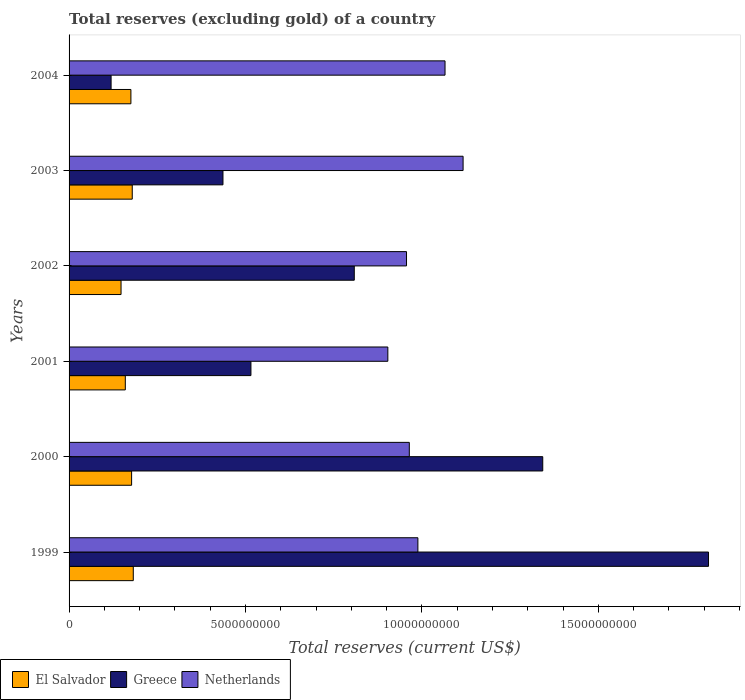How many groups of bars are there?
Provide a short and direct response. 6. Are the number of bars on each tick of the Y-axis equal?
Your response must be concise. Yes. How many bars are there on the 5th tick from the top?
Keep it short and to the point. 3. How many bars are there on the 2nd tick from the bottom?
Ensure brevity in your answer.  3. What is the label of the 5th group of bars from the top?
Provide a succinct answer. 2000. What is the total reserves (excluding gold) in Netherlands in 2001?
Offer a very short reply. 9.03e+09. Across all years, what is the maximum total reserves (excluding gold) in Netherlands?
Offer a very short reply. 1.12e+1. Across all years, what is the minimum total reserves (excluding gold) in Netherlands?
Keep it short and to the point. 9.03e+09. What is the total total reserves (excluding gold) in Netherlands in the graph?
Offer a terse response. 5.99e+1. What is the difference between the total reserves (excluding gold) in Netherlands in 2000 and that in 2002?
Make the answer very short. 7.93e+07. What is the difference between the total reserves (excluding gold) in El Salvador in 2000 and the total reserves (excluding gold) in Netherlands in 1999?
Give a very brief answer. -8.11e+09. What is the average total reserves (excluding gold) in El Salvador per year?
Your response must be concise. 1.70e+09. In the year 2003, what is the difference between the total reserves (excluding gold) in El Salvador and total reserves (excluding gold) in Greece?
Offer a very short reply. -2.57e+09. What is the ratio of the total reserves (excluding gold) in Netherlands in 2000 to that in 2002?
Your response must be concise. 1.01. Is the difference between the total reserves (excluding gold) in El Salvador in 1999 and 2004 greater than the difference between the total reserves (excluding gold) in Greece in 1999 and 2004?
Make the answer very short. No. What is the difference between the highest and the second highest total reserves (excluding gold) in Netherlands?
Keep it short and to the point. 5.12e+08. What is the difference between the highest and the lowest total reserves (excluding gold) in El Salvador?
Provide a succinct answer. 3.47e+08. Is the sum of the total reserves (excluding gold) in El Salvador in 2001 and 2003 greater than the maximum total reserves (excluding gold) in Netherlands across all years?
Your response must be concise. No. What does the 2nd bar from the top in 2001 represents?
Provide a succinct answer. Greece. What does the 2nd bar from the bottom in 2000 represents?
Provide a short and direct response. Greece. How many bars are there?
Give a very brief answer. 18. Are the values on the major ticks of X-axis written in scientific E-notation?
Ensure brevity in your answer.  No. Does the graph contain any zero values?
Make the answer very short. No. Where does the legend appear in the graph?
Ensure brevity in your answer.  Bottom left. How many legend labels are there?
Offer a very short reply. 3. How are the legend labels stacked?
Offer a very short reply. Horizontal. What is the title of the graph?
Keep it short and to the point. Total reserves (excluding gold) of a country. What is the label or title of the X-axis?
Your answer should be very brief. Total reserves (current US$). What is the label or title of the Y-axis?
Give a very brief answer. Years. What is the Total reserves (current US$) in El Salvador in 1999?
Provide a succinct answer. 1.82e+09. What is the Total reserves (current US$) of Greece in 1999?
Your response must be concise. 1.81e+1. What is the Total reserves (current US$) of Netherlands in 1999?
Ensure brevity in your answer.  9.89e+09. What is the Total reserves (current US$) in El Salvador in 2000?
Provide a short and direct response. 1.77e+09. What is the Total reserves (current US$) of Greece in 2000?
Make the answer very short. 1.34e+1. What is the Total reserves (current US$) of Netherlands in 2000?
Offer a very short reply. 9.64e+09. What is the Total reserves (current US$) in El Salvador in 2001?
Ensure brevity in your answer.  1.59e+09. What is the Total reserves (current US$) of Greece in 2001?
Provide a succinct answer. 5.15e+09. What is the Total reserves (current US$) of Netherlands in 2001?
Keep it short and to the point. 9.03e+09. What is the Total reserves (current US$) of El Salvador in 2002?
Your response must be concise. 1.47e+09. What is the Total reserves (current US$) of Greece in 2002?
Provide a succinct answer. 8.08e+09. What is the Total reserves (current US$) in Netherlands in 2002?
Provide a short and direct response. 9.56e+09. What is the Total reserves (current US$) in El Salvador in 2003?
Your answer should be compact. 1.79e+09. What is the Total reserves (current US$) of Greece in 2003?
Offer a terse response. 4.36e+09. What is the Total reserves (current US$) of Netherlands in 2003?
Provide a succinct answer. 1.12e+1. What is the Total reserves (current US$) in El Salvador in 2004?
Give a very brief answer. 1.75e+09. What is the Total reserves (current US$) in Greece in 2004?
Provide a short and direct response. 1.19e+09. What is the Total reserves (current US$) in Netherlands in 2004?
Your response must be concise. 1.07e+1. Across all years, what is the maximum Total reserves (current US$) in El Salvador?
Give a very brief answer. 1.82e+09. Across all years, what is the maximum Total reserves (current US$) in Greece?
Offer a terse response. 1.81e+1. Across all years, what is the maximum Total reserves (current US$) of Netherlands?
Your answer should be very brief. 1.12e+1. Across all years, what is the minimum Total reserves (current US$) of El Salvador?
Ensure brevity in your answer.  1.47e+09. Across all years, what is the minimum Total reserves (current US$) of Greece?
Provide a succinct answer. 1.19e+09. Across all years, what is the minimum Total reserves (current US$) of Netherlands?
Your response must be concise. 9.03e+09. What is the total Total reserves (current US$) in El Salvador in the graph?
Offer a terse response. 1.02e+1. What is the total Total reserves (current US$) of Greece in the graph?
Your response must be concise. 5.03e+1. What is the total Total reserves (current US$) in Netherlands in the graph?
Give a very brief answer. 5.99e+1. What is the difference between the Total reserves (current US$) in El Salvador in 1999 and that in 2000?
Make the answer very short. 4.72e+07. What is the difference between the Total reserves (current US$) of Greece in 1999 and that in 2000?
Ensure brevity in your answer.  4.70e+09. What is the difference between the Total reserves (current US$) of Netherlands in 1999 and that in 2000?
Your answer should be very brief. 2.43e+08. What is the difference between the Total reserves (current US$) of El Salvador in 1999 and that in 2001?
Give a very brief answer. 2.26e+08. What is the difference between the Total reserves (current US$) of Greece in 1999 and that in 2001?
Keep it short and to the point. 1.30e+1. What is the difference between the Total reserves (current US$) of Netherlands in 1999 and that in 2001?
Provide a short and direct response. 8.51e+08. What is the difference between the Total reserves (current US$) in El Salvador in 1999 and that in 2002?
Offer a very short reply. 3.47e+08. What is the difference between the Total reserves (current US$) in Greece in 1999 and that in 2002?
Make the answer very short. 1.00e+1. What is the difference between the Total reserves (current US$) in Netherlands in 1999 and that in 2002?
Your answer should be very brief. 3.22e+08. What is the difference between the Total reserves (current US$) in El Salvador in 1999 and that in 2003?
Give a very brief answer. 2.91e+07. What is the difference between the Total reserves (current US$) of Greece in 1999 and that in 2003?
Keep it short and to the point. 1.38e+1. What is the difference between the Total reserves (current US$) in Netherlands in 1999 and that in 2003?
Keep it short and to the point. -1.28e+09. What is the difference between the Total reserves (current US$) of El Salvador in 1999 and that in 2004?
Offer a very short reply. 6.74e+07. What is the difference between the Total reserves (current US$) in Greece in 1999 and that in 2004?
Ensure brevity in your answer.  1.69e+1. What is the difference between the Total reserves (current US$) of Netherlands in 1999 and that in 2004?
Keep it short and to the point. -7.69e+08. What is the difference between the Total reserves (current US$) in El Salvador in 2000 and that in 2001?
Provide a succinct answer. 1.79e+08. What is the difference between the Total reserves (current US$) of Greece in 2000 and that in 2001?
Your answer should be compact. 8.27e+09. What is the difference between the Total reserves (current US$) of Netherlands in 2000 and that in 2001?
Your answer should be compact. 6.08e+08. What is the difference between the Total reserves (current US$) in El Salvador in 2000 and that in 2002?
Provide a short and direct response. 3.00e+08. What is the difference between the Total reserves (current US$) of Greece in 2000 and that in 2002?
Offer a very short reply. 5.34e+09. What is the difference between the Total reserves (current US$) of Netherlands in 2000 and that in 2002?
Offer a terse response. 7.93e+07. What is the difference between the Total reserves (current US$) of El Salvador in 2000 and that in 2003?
Ensure brevity in your answer.  -1.81e+07. What is the difference between the Total reserves (current US$) in Greece in 2000 and that in 2003?
Make the answer very short. 9.06e+09. What is the difference between the Total reserves (current US$) of Netherlands in 2000 and that in 2003?
Your response must be concise. -1.52e+09. What is the difference between the Total reserves (current US$) of El Salvador in 2000 and that in 2004?
Offer a very short reply. 2.02e+07. What is the difference between the Total reserves (current US$) of Greece in 2000 and that in 2004?
Offer a terse response. 1.22e+1. What is the difference between the Total reserves (current US$) of Netherlands in 2000 and that in 2004?
Ensure brevity in your answer.  -1.01e+09. What is the difference between the Total reserves (current US$) of El Salvador in 2001 and that in 2002?
Offer a very short reply. 1.21e+08. What is the difference between the Total reserves (current US$) in Greece in 2001 and that in 2002?
Your answer should be very brief. -2.93e+09. What is the difference between the Total reserves (current US$) of Netherlands in 2001 and that in 2002?
Provide a succinct answer. -5.29e+08. What is the difference between the Total reserves (current US$) of El Salvador in 2001 and that in 2003?
Your answer should be very brief. -1.97e+08. What is the difference between the Total reserves (current US$) in Greece in 2001 and that in 2003?
Ensure brevity in your answer.  7.93e+08. What is the difference between the Total reserves (current US$) in Netherlands in 2001 and that in 2003?
Your answer should be very brief. -2.13e+09. What is the difference between the Total reserves (current US$) in El Salvador in 2001 and that in 2004?
Give a very brief answer. -1.59e+08. What is the difference between the Total reserves (current US$) of Greece in 2001 and that in 2004?
Your response must be concise. 3.96e+09. What is the difference between the Total reserves (current US$) of Netherlands in 2001 and that in 2004?
Your answer should be compact. -1.62e+09. What is the difference between the Total reserves (current US$) of El Salvador in 2002 and that in 2003?
Make the answer very short. -3.18e+08. What is the difference between the Total reserves (current US$) of Greece in 2002 and that in 2003?
Give a very brief answer. 3.72e+09. What is the difference between the Total reserves (current US$) in Netherlands in 2002 and that in 2003?
Your response must be concise. -1.60e+09. What is the difference between the Total reserves (current US$) in El Salvador in 2002 and that in 2004?
Your answer should be compact. -2.80e+08. What is the difference between the Total reserves (current US$) in Greece in 2002 and that in 2004?
Ensure brevity in your answer.  6.89e+09. What is the difference between the Total reserves (current US$) in Netherlands in 2002 and that in 2004?
Offer a terse response. -1.09e+09. What is the difference between the Total reserves (current US$) of El Salvador in 2003 and that in 2004?
Provide a short and direct response. 3.83e+07. What is the difference between the Total reserves (current US$) of Greece in 2003 and that in 2004?
Provide a succinct answer. 3.17e+09. What is the difference between the Total reserves (current US$) in Netherlands in 2003 and that in 2004?
Provide a succinct answer. 5.12e+08. What is the difference between the Total reserves (current US$) of El Salvador in 1999 and the Total reserves (current US$) of Greece in 2000?
Keep it short and to the point. -1.16e+1. What is the difference between the Total reserves (current US$) in El Salvador in 1999 and the Total reserves (current US$) in Netherlands in 2000?
Provide a succinct answer. -7.82e+09. What is the difference between the Total reserves (current US$) of Greece in 1999 and the Total reserves (current US$) of Netherlands in 2000?
Your response must be concise. 8.48e+09. What is the difference between the Total reserves (current US$) in El Salvador in 1999 and the Total reserves (current US$) in Greece in 2001?
Ensure brevity in your answer.  -3.33e+09. What is the difference between the Total reserves (current US$) in El Salvador in 1999 and the Total reserves (current US$) in Netherlands in 2001?
Your answer should be compact. -7.21e+09. What is the difference between the Total reserves (current US$) in Greece in 1999 and the Total reserves (current US$) in Netherlands in 2001?
Your answer should be compact. 9.09e+09. What is the difference between the Total reserves (current US$) in El Salvador in 1999 and the Total reserves (current US$) in Greece in 2002?
Give a very brief answer. -6.26e+09. What is the difference between the Total reserves (current US$) of El Salvador in 1999 and the Total reserves (current US$) of Netherlands in 2002?
Make the answer very short. -7.74e+09. What is the difference between the Total reserves (current US$) in Greece in 1999 and the Total reserves (current US$) in Netherlands in 2002?
Offer a very short reply. 8.56e+09. What is the difference between the Total reserves (current US$) in El Salvador in 1999 and the Total reserves (current US$) in Greece in 2003?
Your response must be concise. -2.54e+09. What is the difference between the Total reserves (current US$) of El Salvador in 1999 and the Total reserves (current US$) of Netherlands in 2003?
Offer a terse response. -9.35e+09. What is the difference between the Total reserves (current US$) of Greece in 1999 and the Total reserves (current US$) of Netherlands in 2003?
Your response must be concise. 6.96e+09. What is the difference between the Total reserves (current US$) of El Salvador in 1999 and the Total reserves (current US$) of Greece in 2004?
Your answer should be very brief. 6.29e+08. What is the difference between the Total reserves (current US$) of El Salvador in 1999 and the Total reserves (current US$) of Netherlands in 2004?
Ensure brevity in your answer.  -8.84e+09. What is the difference between the Total reserves (current US$) in Greece in 1999 and the Total reserves (current US$) in Netherlands in 2004?
Offer a very short reply. 7.47e+09. What is the difference between the Total reserves (current US$) of El Salvador in 2000 and the Total reserves (current US$) of Greece in 2001?
Offer a very short reply. -3.38e+09. What is the difference between the Total reserves (current US$) of El Salvador in 2000 and the Total reserves (current US$) of Netherlands in 2001?
Ensure brevity in your answer.  -7.26e+09. What is the difference between the Total reserves (current US$) of Greece in 2000 and the Total reserves (current US$) of Netherlands in 2001?
Offer a very short reply. 4.39e+09. What is the difference between the Total reserves (current US$) in El Salvador in 2000 and the Total reserves (current US$) in Greece in 2002?
Keep it short and to the point. -6.31e+09. What is the difference between the Total reserves (current US$) in El Salvador in 2000 and the Total reserves (current US$) in Netherlands in 2002?
Provide a short and direct response. -7.79e+09. What is the difference between the Total reserves (current US$) in Greece in 2000 and the Total reserves (current US$) in Netherlands in 2002?
Your answer should be very brief. 3.86e+09. What is the difference between the Total reserves (current US$) of El Salvador in 2000 and the Total reserves (current US$) of Greece in 2003?
Offer a terse response. -2.59e+09. What is the difference between the Total reserves (current US$) in El Salvador in 2000 and the Total reserves (current US$) in Netherlands in 2003?
Keep it short and to the point. -9.39e+09. What is the difference between the Total reserves (current US$) of Greece in 2000 and the Total reserves (current US$) of Netherlands in 2003?
Provide a succinct answer. 2.26e+09. What is the difference between the Total reserves (current US$) in El Salvador in 2000 and the Total reserves (current US$) in Greece in 2004?
Provide a short and direct response. 5.82e+08. What is the difference between the Total reserves (current US$) of El Salvador in 2000 and the Total reserves (current US$) of Netherlands in 2004?
Offer a terse response. -8.88e+09. What is the difference between the Total reserves (current US$) in Greece in 2000 and the Total reserves (current US$) in Netherlands in 2004?
Make the answer very short. 2.77e+09. What is the difference between the Total reserves (current US$) of El Salvador in 2001 and the Total reserves (current US$) of Greece in 2002?
Make the answer very short. -6.49e+09. What is the difference between the Total reserves (current US$) of El Salvador in 2001 and the Total reserves (current US$) of Netherlands in 2002?
Ensure brevity in your answer.  -7.97e+09. What is the difference between the Total reserves (current US$) of Greece in 2001 and the Total reserves (current US$) of Netherlands in 2002?
Ensure brevity in your answer.  -4.41e+09. What is the difference between the Total reserves (current US$) in El Salvador in 2001 and the Total reserves (current US$) in Greece in 2003?
Keep it short and to the point. -2.77e+09. What is the difference between the Total reserves (current US$) of El Salvador in 2001 and the Total reserves (current US$) of Netherlands in 2003?
Provide a short and direct response. -9.57e+09. What is the difference between the Total reserves (current US$) in Greece in 2001 and the Total reserves (current US$) in Netherlands in 2003?
Your answer should be compact. -6.01e+09. What is the difference between the Total reserves (current US$) in El Salvador in 2001 and the Total reserves (current US$) in Greece in 2004?
Your answer should be very brief. 4.03e+08. What is the difference between the Total reserves (current US$) in El Salvador in 2001 and the Total reserves (current US$) in Netherlands in 2004?
Your response must be concise. -9.06e+09. What is the difference between the Total reserves (current US$) in Greece in 2001 and the Total reserves (current US$) in Netherlands in 2004?
Ensure brevity in your answer.  -5.50e+09. What is the difference between the Total reserves (current US$) in El Salvador in 2002 and the Total reserves (current US$) in Greece in 2003?
Make the answer very short. -2.89e+09. What is the difference between the Total reserves (current US$) in El Salvador in 2002 and the Total reserves (current US$) in Netherlands in 2003?
Keep it short and to the point. -9.69e+09. What is the difference between the Total reserves (current US$) of Greece in 2002 and the Total reserves (current US$) of Netherlands in 2003?
Your answer should be compact. -3.08e+09. What is the difference between the Total reserves (current US$) of El Salvador in 2002 and the Total reserves (current US$) of Greece in 2004?
Provide a short and direct response. 2.82e+08. What is the difference between the Total reserves (current US$) in El Salvador in 2002 and the Total reserves (current US$) in Netherlands in 2004?
Offer a terse response. -9.18e+09. What is the difference between the Total reserves (current US$) of Greece in 2002 and the Total reserves (current US$) of Netherlands in 2004?
Your response must be concise. -2.57e+09. What is the difference between the Total reserves (current US$) in El Salvador in 2003 and the Total reserves (current US$) in Greece in 2004?
Provide a succinct answer. 6.00e+08. What is the difference between the Total reserves (current US$) of El Salvador in 2003 and the Total reserves (current US$) of Netherlands in 2004?
Provide a succinct answer. -8.86e+09. What is the difference between the Total reserves (current US$) of Greece in 2003 and the Total reserves (current US$) of Netherlands in 2004?
Provide a succinct answer. -6.29e+09. What is the average Total reserves (current US$) of El Salvador per year?
Provide a short and direct response. 1.70e+09. What is the average Total reserves (current US$) in Greece per year?
Your answer should be compact. 8.39e+09. What is the average Total reserves (current US$) of Netherlands per year?
Provide a succinct answer. 9.99e+09. In the year 1999, what is the difference between the Total reserves (current US$) in El Salvador and Total reserves (current US$) in Greece?
Your response must be concise. -1.63e+1. In the year 1999, what is the difference between the Total reserves (current US$) in El Salvador and Total reserves (current US$) in Netherlands?
Offer a very short reply. -8.07e+09. In the year 1999, what is the difference between the Total reserves (current US$) in Greece and Total reserves (current US$) in Netherlands?
Make the answer very short. 8.24e+09. In the year 2000, what is the difference between the Total reserves (current US$) of El Salvador and Total reserves (current US$) of Greece?
Your answer should be very brief. -1.17e+1. In the year 2000, what is the difference between the Total reserves (current US$) in El Salvador and Total reserves (current US$) in Netherlands?
Keep it short and to the point. -7.87e+09. In the year 2000, what is the difference between the Total reserves (current US$) of Greece and Total reserves (current US$) of Netherlands?
Provide a short and direct response. 3.78e+09. In the year 2001, what is the difference between the Total reserves (current US$) of El Salvador and Total reserves (current US$) of Greece?
Offer a very short reply. -3.56e+09. In the year 2001, what is the difference between the Total reserves (current US$) in El Salvador and Total reserves (current US$) in Netherlands?
Your answer should be very brief. -7.44e+09. In the year 2001, what is the difference between the Total reserves (current US$) in Greece and Total reserves (current US$) in Netherlands?
Give a very brief answer. -3.88e+09. In the year 2002, what is the difference between the Total reserves (current US$) in El Salvador and Total reserves (current US$) in Greece?
Keep it short and to the point. -6.61e+09. In the year 2002, what is the difference between the Total reserves (current US$) of El Salvador and Total reserves (current US$) of Netherlands?
Provide a short and direct response. -8.09e+09. In the year 2002, what is the difference between the Total reserves (current US$) of Greece and Total reserves (current US$) of Netherlands?
Give a very brief answer. -1.48e+09. In the year 2003, what is the difference between the Total reserves (current US$) of El Salvador and Total reserves (current US$) of Greece?
Ensure brevity in your answer.  -2.57e+09. In the year 2003, what is the difference between the Total reserves (current US$) in El Salvador and Total reserves (current US$) in Netherlands?
Provide a succinct answer. -9.38e+09. In the year 2003, what is the difference between the Total reserves (current US$) in Greece and Total reserves (current US$) in Netherlands?
Make the answer very short. -6.81e+09. In the year 2004, what is the difference between the Total reserves (current US$) in El Salvador and Total reserves (current US$) in Greece?
Provide a succinct answer. 5.61e+08. In the year 2004, what is the difference between the Total reserves (current US$) of El Salvador and Total reserves (current US$) of Netherlands?
Your response must be concise. -8.90e+09. In the year 2004, what is the difference between the Total reserves (current US$) of Greece and Total reserves (current US$) of Netherlands?
Offer a terse response. -9.46e+09. What is the ratio of the Total reserves (current US$) of El Salvador in 1999 to that in 2000?
Ensure brevity in your answer.  1.03. What is the ratio of the Total reserves (current US$) of Greece in 1999 to that in 2000?
Make the answer very short. 1.35. What is the ratio of the Total reserves (current US$) of Netherlands in 1999 to that in 2000?
Provide a short and direct response. 1.03. What is the ratio of the Total reserves (current US$) in El Salvador in 1999 to that in 2001?
Give a very brief answer. 1.14. What is the ratio of the Total reserves (current US$) of Greece in 1999 to that in 2001?
Offer a very short reply. 3.52. What is the ratio of the Total reserves (current US$) of Netherlands in 1999 to that in 2001?
Provide a succinct answer. 1.09. What is the ratio of the Total reserves (current US$) in El Salvador in 1999 to that in 2002?
Provide a succinct answer. 1.24. What is the ratio of the Total reserves (current US$) in Greece in 1999 to that in 2002?
Provide a short and direct response. 2.24. What is the ratio of the Total reserves (current US$) of Netherlands in 1999 to that in 2002?
Offer a terse response. 1.03. What is the ratio of the Total reserves (current US$) in El Salvador in 1999 to that in 2003?
Your answer should be compact. 1.02. What is the ratio of the Total reserves (current US$) of Greece in 1999 to that in 2003?
Ensure brevity in your answer.  4.16. What is the ratio of the Total reserves (current US$) of Netherlands in 1999 to that in 2003?
Offer a very short reply. 0.89. What is the ratio of the Total reserves (current US$) in Greece in 1999 to that in 2004?
Offer a very short reply. 15.22. What is the ratio of the Total reserves (current US$) of Netherlands in 1999 to that in 2004?
Your answer should be very brief. 0.93. What is the ratio of the Total reserves (current US$) in El Salvador in 2000 to that in 2001?
Provide a succinct answer. 1.11. What is the ratio of the Total reserves (current US$) of Greece in 2000 to that in 2001?
Ensure brevity in your answer.  2.6. What is the ratio of the Total reserves (current US$) of Netherlands in 2000 to that in 2001?
Your response must be concise. 1.07. What is the ratio of the Total reserves (current US$) of El Salvador in 2000 to that in 2002?
Ensure brevity in your answer.  1.2. What is the ratio of the Total reserves (current US$) of Greece in 2000 to that in 2002?
Give a very brief answer. 1.66. What is the ratio of the Total reserves (current US$) of Netherlands in 2000 to that in 2002?
Offer a very short reply. 1.01. What is the ratio of the Total reserves (current US$) in Greece in 2000 to that in 2003?
Provide a succinct answer. 3.08. What is the ratio of the Total reserves (current US$) in Netherlands in 2000 to that in 2003?
Ensure brevity in your answer.  0.86. What is the ratio of the Total reserves (current US$) in El Salvador in 2000 to that in 2004?
Your answer should be compact. 1.01. What is the ratio of the Total reserves (current US$) in Greece in 2000 to that in 2004?
Your response must be concise. 11.27. What is the ratio of the Total reserves (current US$) of Netherlands in 2000 to that in 2004?
Give a very brief answer. 0.91. What is the ratio of the Total reserves (current US$) in El Salvador in 2001 to that in 2002?
Make the answer very short. 1.08. What is the ratio of the Total reserves (current US$) in Greece in 2001 to that in 2002?
Make the answer very short. 0.64. What is the ratio of the Total reserves (current US$) of Netherlands in 2001 to that in 2002?
Offer a terse response. 0.94. What is the ratio of the Total reserves (current US$) of El Salvador in 2001 to that in 2003?
Offer a terse response. 0.89. What is the ratio of the Total reserves (current US$) of Greece in 2001 to that in 2003?
Provide a short and direct response. 1.18. What is the ratio of the Total reserves (current US$) in Netherlands in 2001 to that in 2003?
Keep it short and to the point. 0.81. What is the ratio of the Total reserves (current US$) in El Salvador in 2001 to that in 2004?
Give a very brief answer. 0.91. What is the ratio of the Total reserves (current US$) of Greece in 2001 to that in 2004?
Your response must be concise. 4.33. What is the ratio of the Total reserves (current US$) in Netherlands in 2001 to that in 2004?
Make the answer very short. 0.85. What is the ratio of the Total reserves (current US$) in El Salvador in 2002 to that in 2003?
Your answer should be very brief. 0.82. What is the ratio of the Total reserves (current US$) in Greece in 2002 to that in 2003?
Your response must be concise. 1.85. What is the ratio of the Total reserves (current US$) in Netherlands in 2002 to that in 2003?
Your answer should be very brief. 0.86. What is the ratio of the Total reserves (current US$) in El Salvador in 2002 to that in 2004?
Give a very brief answer. 0.84. What is the ratio of the Total reserves (current US$) of Greece in 2002 to that in 2004?
Provide a succinct answer. 6.79. What is the ratio of the Total reserves (current US$) of Netherlands in 2002 to that in 2004?
Offer a very short reply. 0.9. What is the ratio of the Total reserves (current US$) in El Salvador in 2003 to that in 2004?
Offer a very short reply. 1.02. What is the ratio of the Total reserves (current US$) in Greece in 2003 to that in 2004?
Make the answer very short. 3.66. What is the ratio of the Total reserves (current US$) of Netherlands in 2003 to that in 2004?
Offer a very short reply. 1.05. What is the difference between the highest and the second highest Total reserves (current US$) of El Salvador?
Give a very brief answer. 2.91e+07. What is the difference between the highest and the second highest Total reserves (current US$) of Greece?
Provide a short and direct response. 4.70e+09. What is the difference between the highest and the second highest Total reserves (current US$) of Netherlands?
Offer a terse response. 5.12e+08. What is the difference between the highest and the lowest Total reserves (current US$) of El Salvador?
Keep it short and to the point. 3.47e+08. What is the difference between the highest and the lowest Total reserves (current US$) in Greece?
Make the answer very short. 1.69e+1. What is the difference between the highest and the lowest Total reserves (current US$) of Netherlands?
Give a very brief answer. 2.13e+09. 